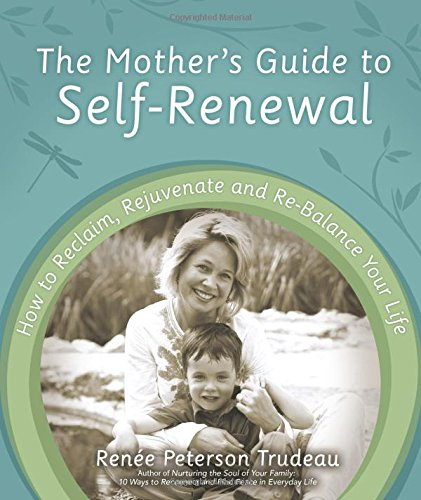What type of book is this? This book is best described as a self-help or personal development guide tailored for mothers looking to find balance and rejuvenation in their lives. 